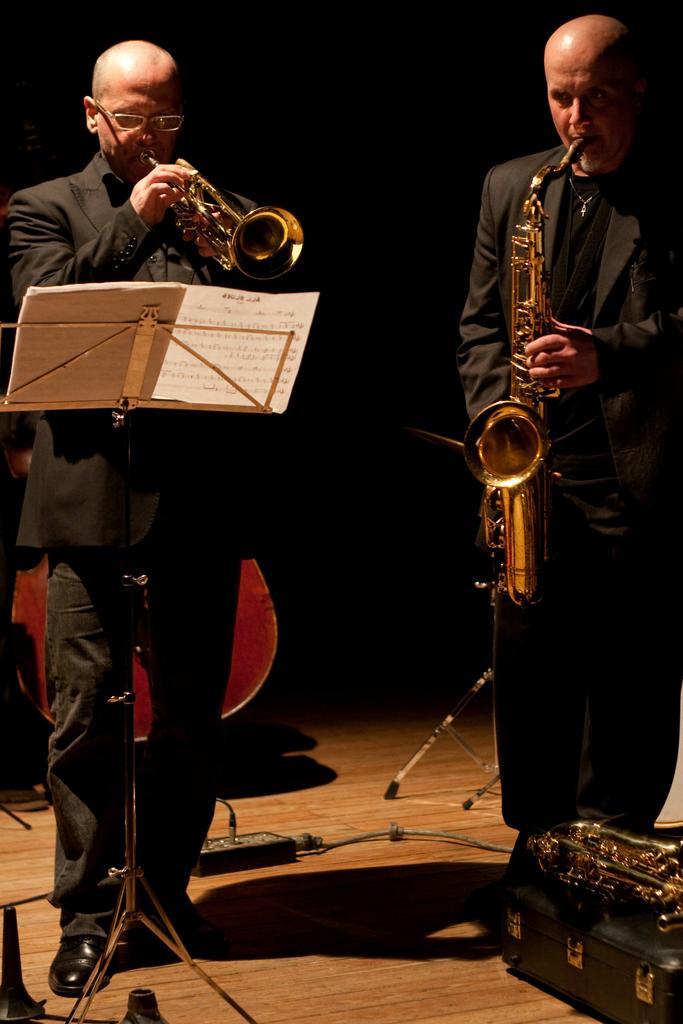Please provide a concise description of this image. In this image we can see few people playing musical instruments. There are few objects on the floor. There is a dark background in the image. 